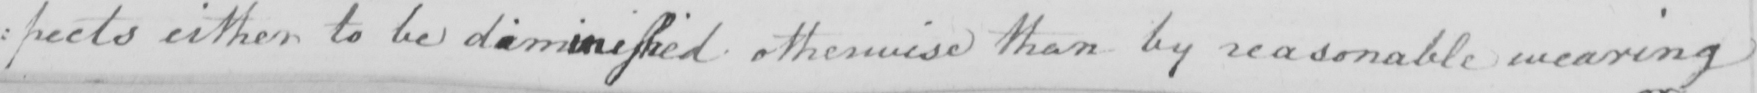Can you tell me what this handwritten text says? : pects either to be diminisshed otherwise than by reasonable wearing 